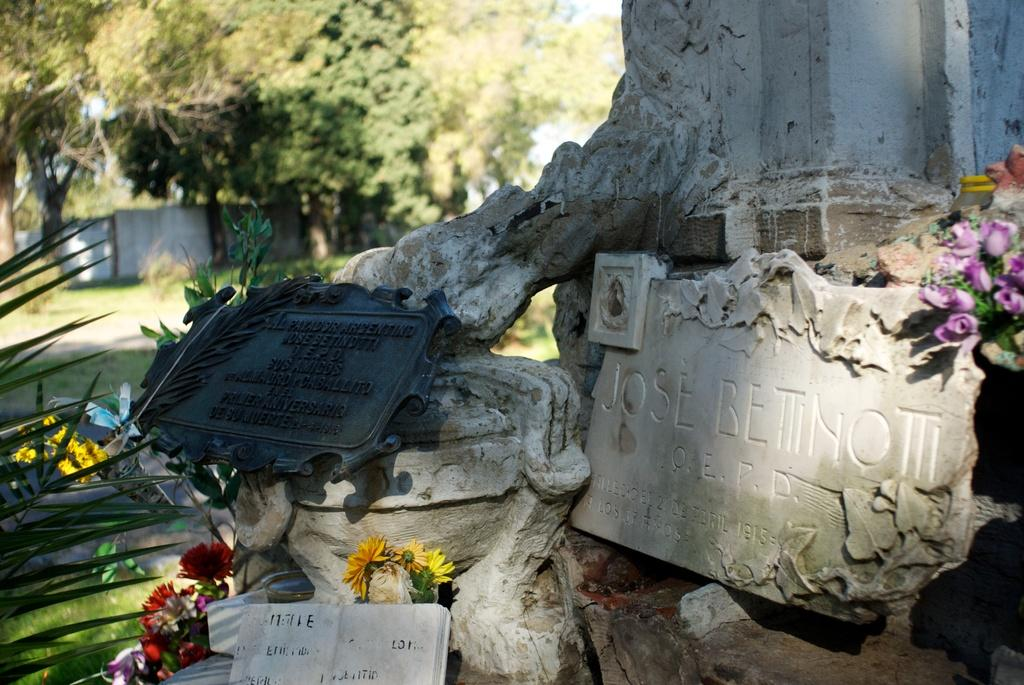What objects in the image have text on them? There are name stones with text in the image. What can be found in the bottom left corner of the image? There are flowers and leaves in the bottom left of the image. What is visible in the top left corner of the image? There are trees in the top left of the image. How many kittens are rolling around in the image? There are no kittens or rolling actions present in the image. 